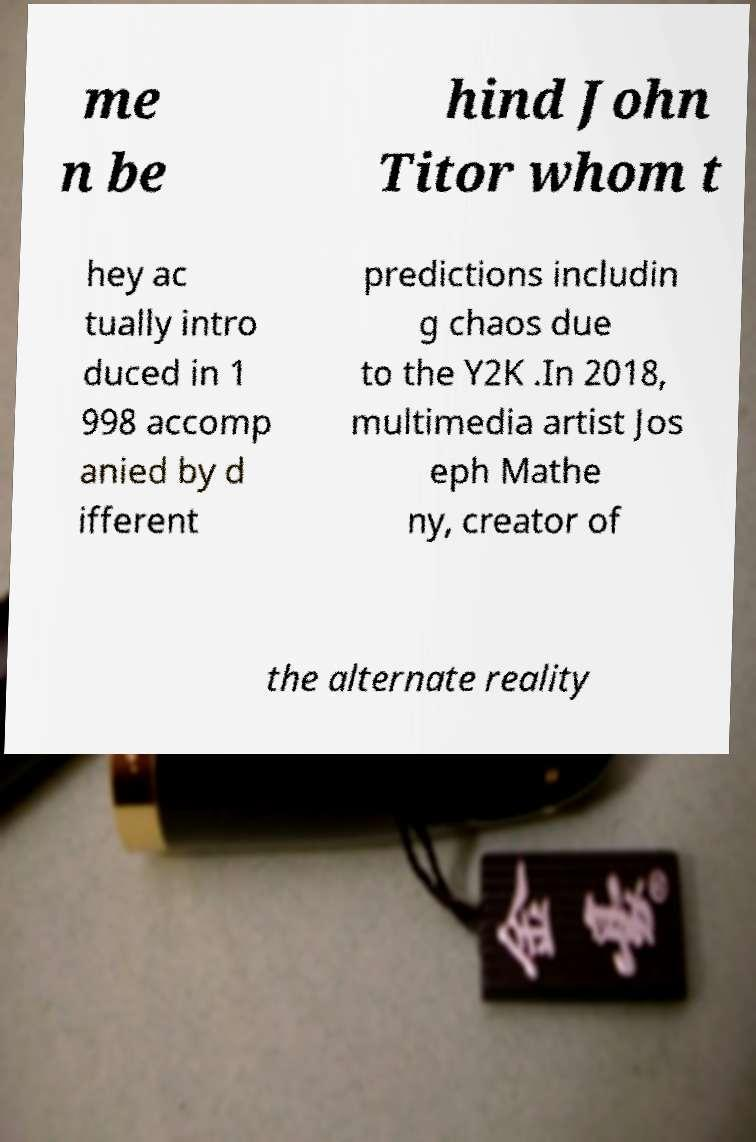Please identify and transcribe the text found in this image. me n be hind John Titor whom t hey ac tually intro duced in 1 998 accomp anied by d ifferent predictions includin g chaos due to the Y2K .In 2018, multimedia artist Jos eph Mathe ny, creator of the alternate reality 